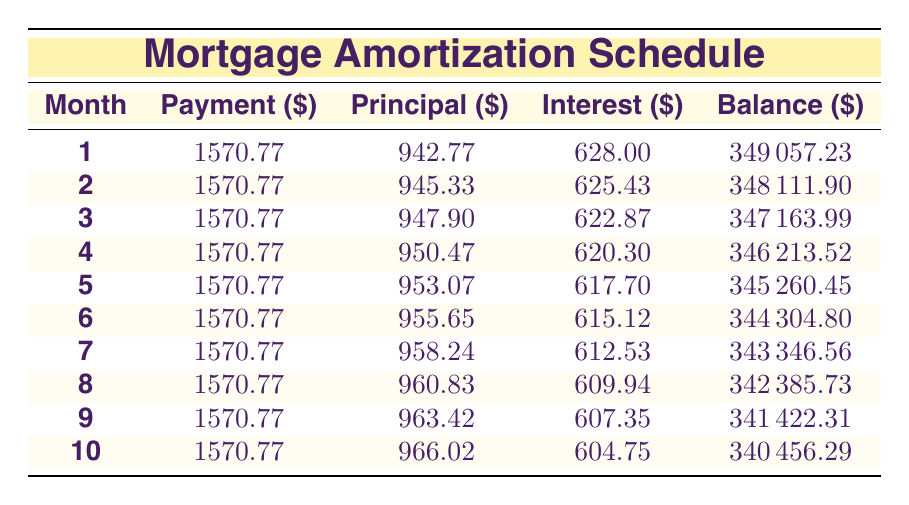What is the monthly payment amount? The monthly payment is listed in the table under the "Payment" column for each month. It shows a consistent value of 1570.77 throughout all the rows.
Answer: 1570.77 What was the principal amount paid in the first month? The table is clear about the amount paid towards the principal in the first month, which is found in the "Principal" column for month 1. That value is 942.77.
Answer: 942.77 Is the interest payment for the second month greater than that for the first month? To answer this, we check the "Interest" column for months 1 and 2. The first month has an interest payment of 628.00 and the second month has 625.43. Since 628.00 > 625.43, the answer is no.
Answer: No What is the total principal paid from months 1 to 3 combined? We sum the principal amounts from the first three months as follows: 942.77 + 945.33 + 947.90 = 2835.00. Thus, the total principal paid from months 1 to 3 is 2835.00.
Answer: 2835.00 What will be the remaining balance after the first month’s payment? The remaining balance is provided in the table under "Balance" for month 1, which is listed as 349057.23.
Answer: 349057.23 How much total interest is paid in the first quarter (first three months)? To find the total interest for the first three months, we sum up the individual interest payments: 628.00 + 625.43 + 622.87 = 1876.30. Hence, the total interest paid in the first quarter is 1876.30.
Answer: 1876.30 Is the balance decreasing consistently each month? We can observe the "Balance" column for each month. Each balance for the subsequent month is lower than the previous month: 349057.23, 348111.90, 347163.99, etc. Thus, the balance decreases consistently.
Answer: Yes What is the average monthly principal payment for the first ten months? To find the average, we first sum the principal payments for the first ten months. Summing these gives a total of 9481.49 (which we calculate by adding all ten principal payments) and we then divide this value by 10. Thus, the average monthly principal payment is 948.15.
Answer: 948.15 How much total payment has been made after ten months? The total payment can be calculated by multiplying the monthly payment by the number of months: 1570.77 * 10 = 15707.70. Therefore, the total payment after ten months is 15707.70.
Answer: 15707.70 